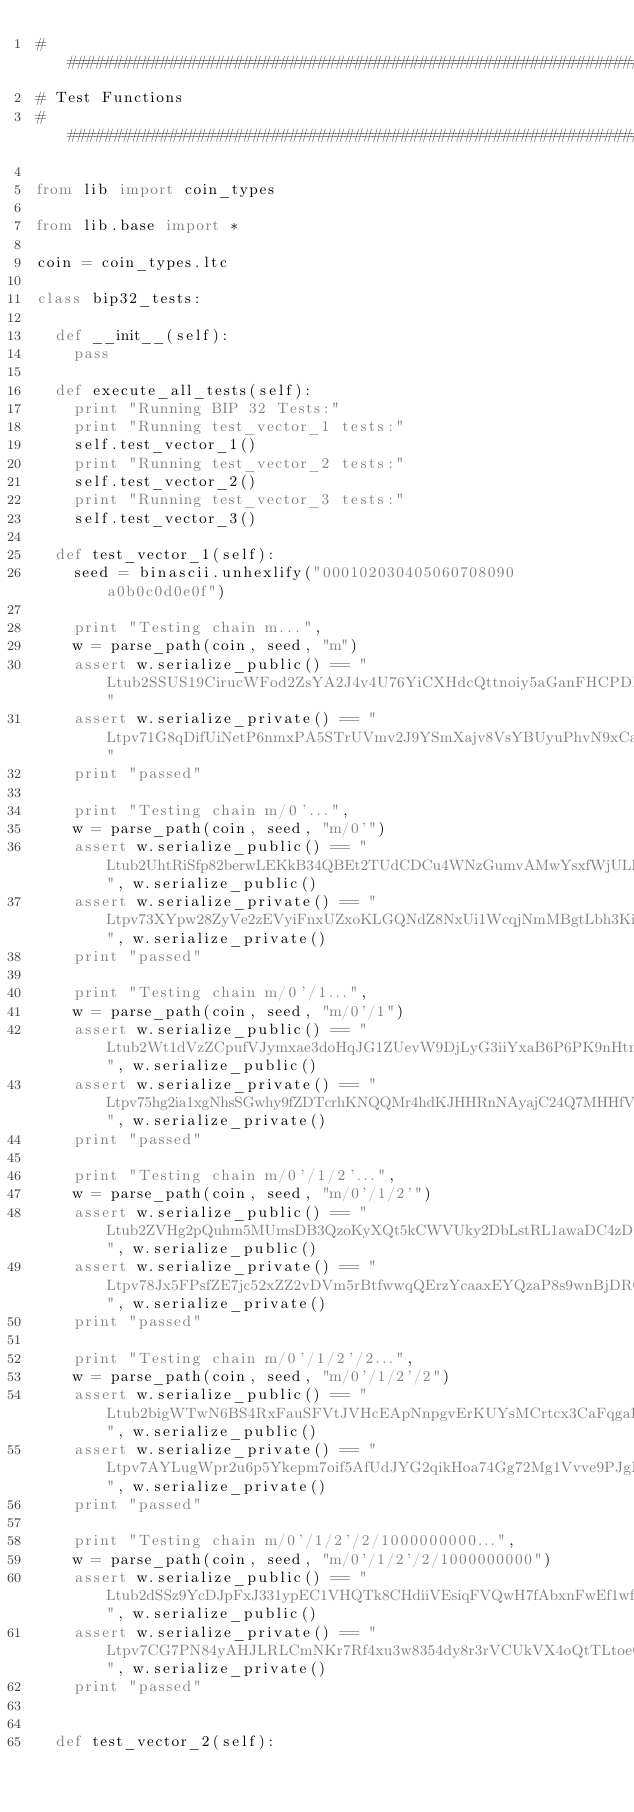Convert code to text. <code><loc_0><loc_0><loc_500><loc_500><_Python_>################################################################################################
# Test Functions
################################################################################################

from lib import coin_types

from lib.base import *

coin = coin_types.ltc

class bip32_tests:

  def __init__(self):
    pass
    
  def execute_all_tests(self):
    print "Running BIP 32 Tests:"
    print "Running test_vector_1 tests:"
    self.test_vector_1()
    print "Running test_vector_2 tests:"
    self.test_vector_2()
    print "Running test_vector_3 tests:"
    self.test_vector_3()
    
  def test_vector_1(self):
    seed = binascii.unhexlify("000102030405060708090a0b0c0d0e0f")
    
    print "Testing chain m...",
    w = parse_path(coin, seed, "m")
    assert w.serialize_public() == "Ltub2SSUS19CirucWFod2ZsYA2J4v4U76YiCXHdcQttnoiy5aGanFHCPDBX7utfG6f95u1cUbZJNafmvzNCzZZJTw1EmyFoL8u1gJbGM8ipu491"
    assert w.serialize_private() == "Ltpv71G8qDifUiNetP6nmxPA5STrUVmv2J9YSmXajv8VsYBUyuPhvN9xCaQrfX2wo5xxJNtEazYCFRUu5FmokYMM79pcqz8pcdo4rNXAFPgyB4k"
    print "passed"
    
    print "Testing chain m/0'...",
    w = parse_path(coin, seed, "m/0'")
    assert w.serialize_public() == "Ltub2UhtRiSfp82berwLEKkB34QBEt2TUdCDCu4WNzGumvAMwYsxfWjULKsXhADxqy3cuDu3TnqoKJr1xmB8Wb2qzthWAtbb4CutpXPuSU1YMgG", w.serialize_public()
    assert w.serialize_private() == "Ltpv73XYpw28ZyVe2zEVyiFnxUZxoKLGQNdZ8NxUi1WcqjNmMBgtLbh3KimGSnPHCoLv1RmvxHs4dnKmo1oXQ8dXuDu8uroxrbVxZPA1gXboYvx", w.serialize_private()
    print "passed"
    
    print "Testing chain m/0'/1...",
    w = parse_path(coin, seed, "m/0'/1")
    assert w.serialize_public() == "Ltub2Wt1dVzZCpufVJymxae3doHqJG1ZUevW9DjLyG3iiYxaB6P6PK9nHtmm7EgYFukxrwX6FDHuRuLVZ4uwyvCjgYXSU6SSXqvATFvgjLDteZ8", w.serialize_public()
    assert w.serialize_private() == "Ltpv75hg2ia1xgNhsSGwhy9fZDTcrhKNQQMr4hdKJHHRnNAyajC24Q7MHHfVrqaLoj7xTWXcm7TViVHBvxKkXURWgPPaRdmgvMGpEBUPDQomMoz", w.serialize_private()
    print "passed"
    
    print "Testing chain m/0'/1/2'...",
    w = parse_path(coin, seed, "m/0'/1/2'")
    assert w.serialize_public() == "Ltub2ZVHg2pQuhm5MUmsDB3QzoKyXQt5kCWVUky2DbLstRL1awaDC4zDCLKgfFsNhnCHDTcprbGWoquU1Q4Eh1kGjzgH3zQacnyrAwqppbnDPZ9", w.serialize_public()
    assert w.serialize_private() == "Ltpv78Jx5FPsfZE7jc52xZZ2vDVm5rBtfwwqQErzYcaaxEYQzaP8s9wnBjDRQsnxmxdSxyZ1MaQR8u76AA4W7VLhoUqEnFLF5HWkqTDbr5DovYB", w.serialize_private()
    print "passed"
    
    print "Testing chain m/0'/1/2'/2...",
    w = parse_path(coin, seed, "m/0'/1/2'/2")
    assert w.serialize_public() == "Ltub2bigWTwN6BS4RxFauSFVtJVHcEApNnpgvErKUYsMCrtcx3CaFqgaPuncLarm7aM1gmjzzbkTraoaZpQEnKBUTb9XxmxmSysgBdkfyFbascs", w.serialize_public()
    assert w.serialize_private() == "Ltpv7AYLugWpr2u6p5Ykepm7oif5AfUdJYG2qikHoa74Gg72Mg1Vvve9PJgM6CCREd2t2mghyVdz3iZFdLxxJut3zsRHBVRLdNLTzRgmMZtMHv7", w.serialize_private()
    print "passed"
    
    print "Testing chain m/0'/1/2'/2/1000000000...",
    w = parse_path(coin, seed, "m/0'/1/2'/2/1000000000")
    assert w.serialize_public() == "Ltub2dSSz9YcDJpFxJ331ypEC1VHQTk8CHdiiVEsiqFVQwH7fAbxnFwEf1wfyQmhxqRjAU2YVwgGPnWBAEoFtAgKJrJeqKNrFTTJzbNbDMUZjYL", w.serialize_public()
    assert w.serialize_private() == "Ltpv7CG7PN84yAHJLRLCmNKr7Rf4xu3w8354dy8r3rVCUkVX4oQtTLtoeQqQj3yd9Y9xeB5xkrcvtm6NdWyKqytn7q4pWzBZkH6BGmF86hsLPtJ", w.serialize_private()
    print "passed"


  def test_vector_2(self):</code> 